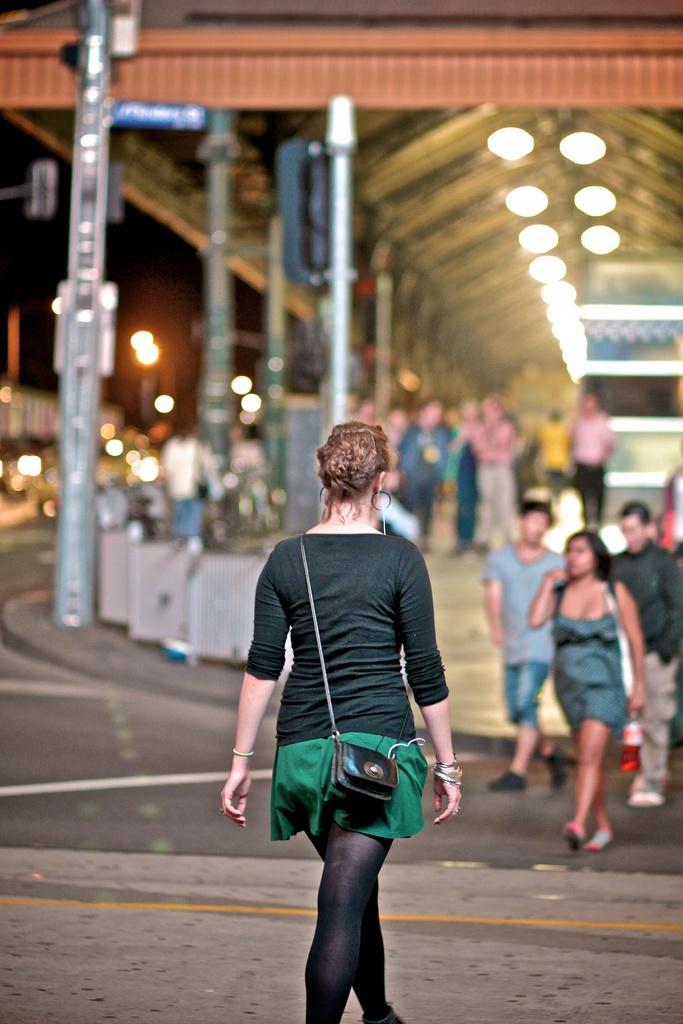How would you summarize this image in a sentence or two? In this image I can see the group of people with different color dresses. These people are on the road. In the background I can see the poles, lights, shed and the black background. I can also see the background is blurred. 